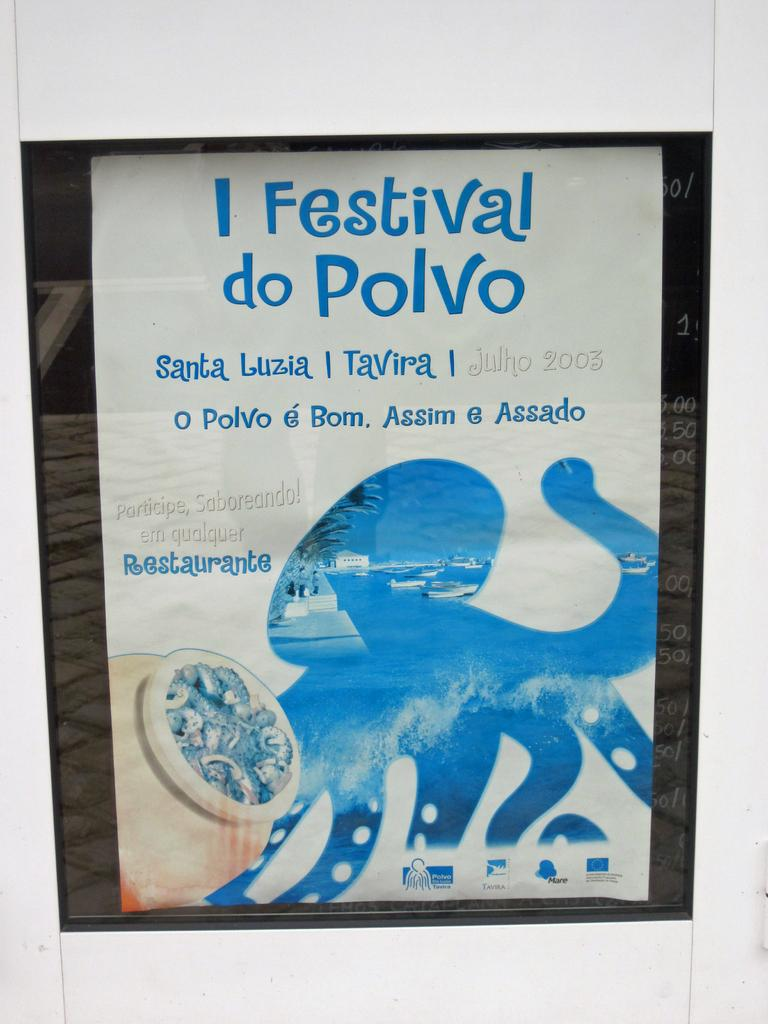<image>
Describe the image concisely. A paper advertises a festival in Santa Luzia. 